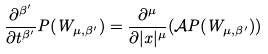<formula> <loc_0><loc_0><loc_500><loc_500>\frac { \partial ^ { \beta ^ { \prime } } } { \partial t ^ { \beta ^ { \prime } } } P ( W _ { \mu , \beta ^ { \prime } } ) = \frac { \partial ^ { \mu } } { \partial | x | ^ { \mu } } ( \mathcal { A } P ( W _ { \mu , \beta ^ { \prime } } ) )</formula> 